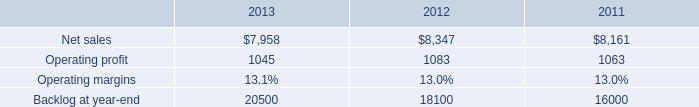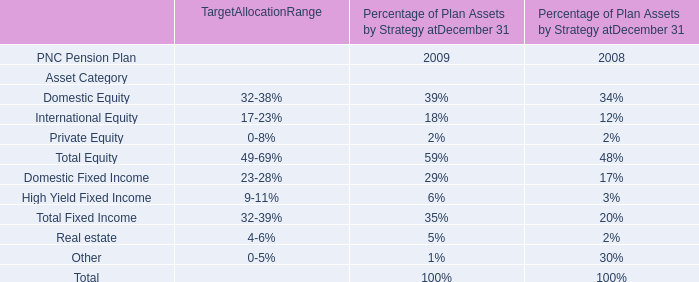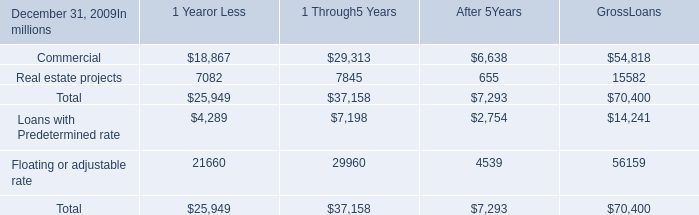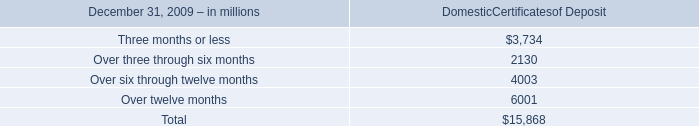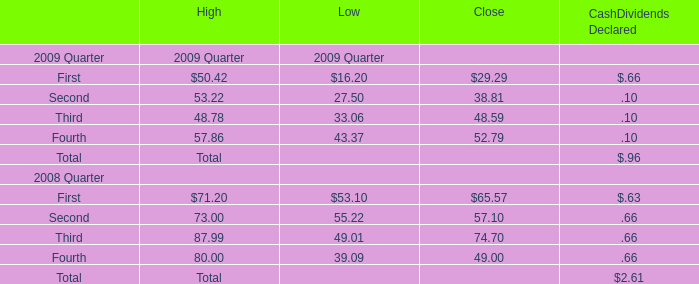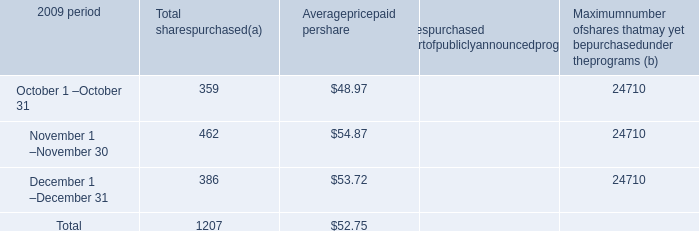what is the highest total amount of First in 2008? 
Computations: ((71.2 + 53.1) + 65.57)
Answer: 189.87. 